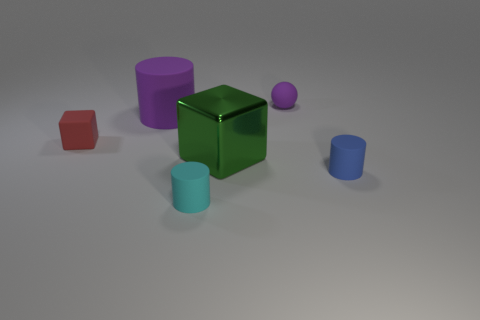Which object in the image seems to reflect the most light? Upon observation, the large green cube seems to reflect the most light, giving it a shiny and glossy appearance. 